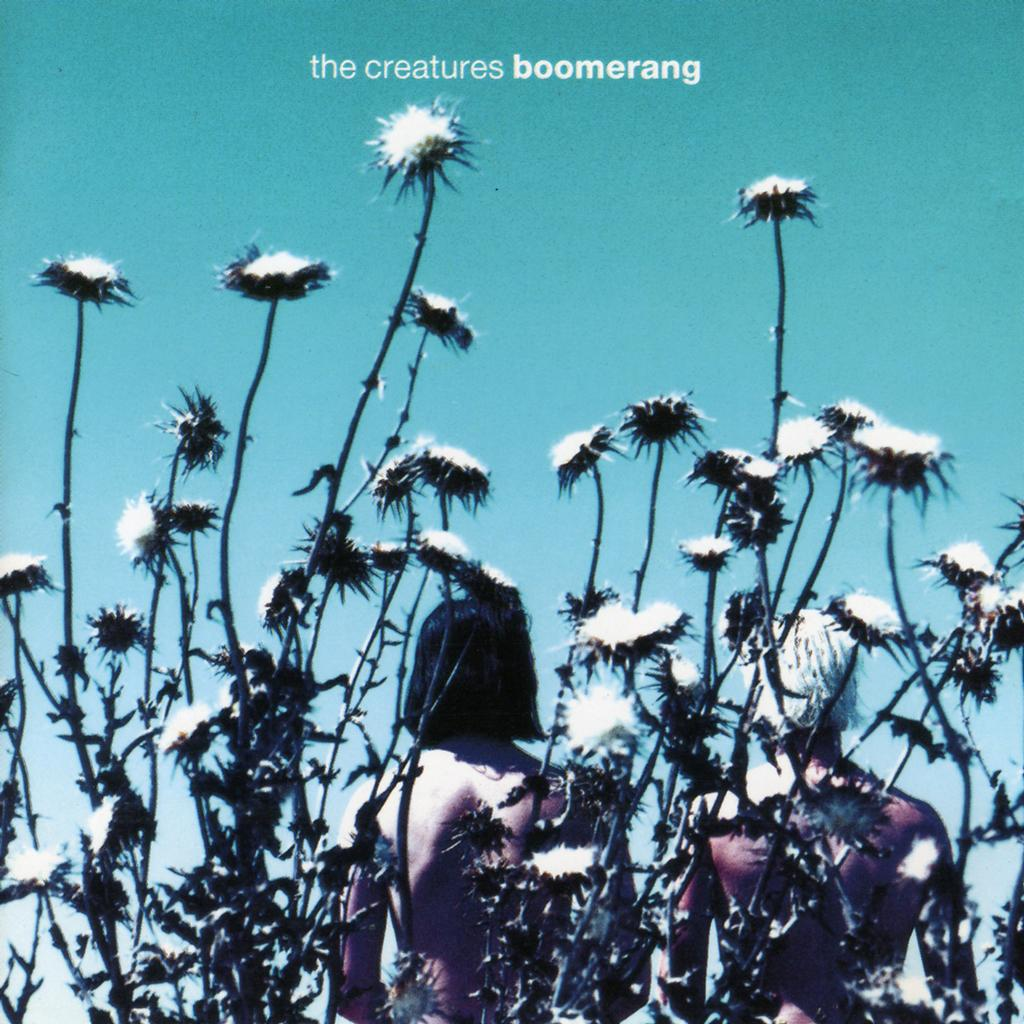What type of vegetation is present in the image? There are trees with flowers in the image. Can you describe the people in the background of the image? There are two persons in the background of the image. What else can be seen at the top of the image besides the trees? There is some written text visible at the top of the image. What type of organization is depicted in the image? There is no organization depicted in the image; it features trees with flowers, two persons in the background, and written text at the top. What angle is the image taken from? The angle from which the image is taken is not mentioned in the provided facts, so it cannot be determined. 